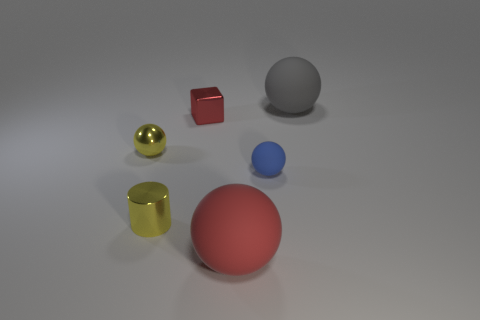Subtract all metallic balls. How many balls are left? 3 Add 1 gray shiny balls. How many objects exist? 7 Subtract all blue spheres. How many spheres are left? 3 Subtract all spheres. How many objects are left? 2 Add 4 small red things. How many small red things are left? 5 Add 4 large red matte balls. How many large red matte balls exist? 5 Subtract 0 red cylinders. How many objects are left? 6 Subtract all gray balls. Subtract all green blocks. How many balls are left? 3 Subtract all yellow rubber cylinders. Subtract all rubber balls. How many objects are left? 3 